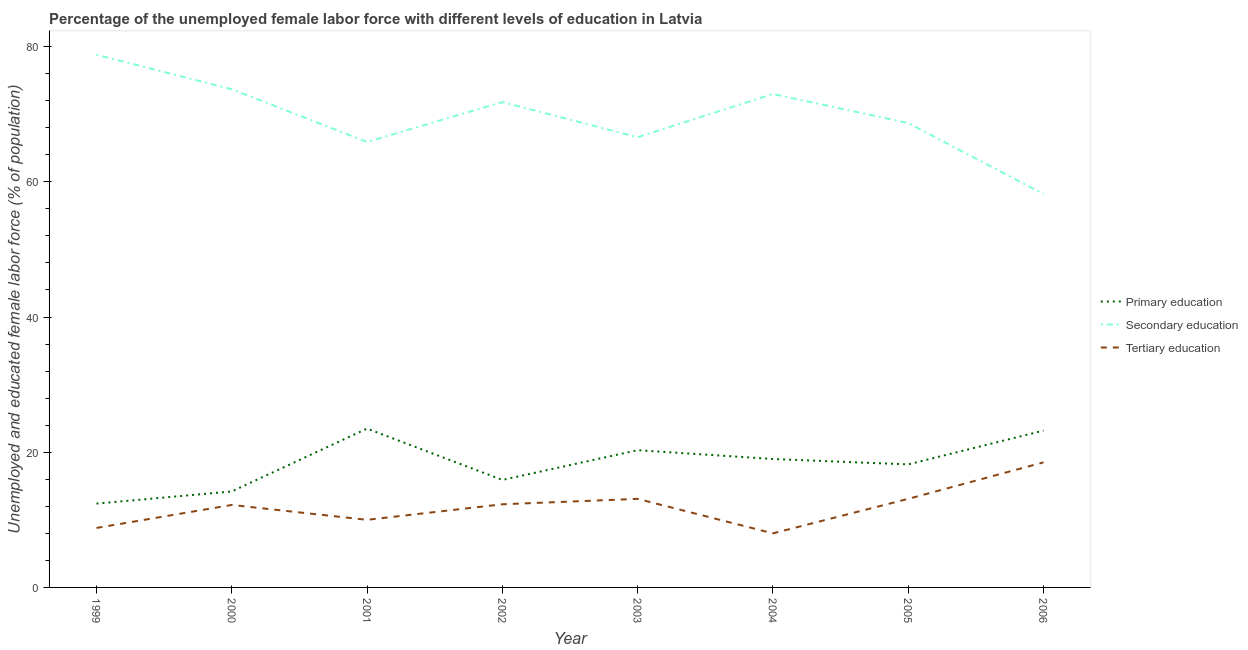How many different coloured lines are there?
Your answer should be very brief. 3. Does the line corresponding to percentage of female labor force who received secondary education intersect with the line corresponding to percentage of female labor force who received tertiary education?
Offer a very short reply. No. What is the percentage of female labor force who received secondary education in 2004?
Give a very brief answer. 73. Across all years, what is the maximum percentage of female labor force who received secondary education?
Make the answer very short. 78.8. What is the total percentage of female labor force who received tertiary education in the graph?
Offer a terse response. 96. What is the difference between the percentage of female labor force who received secondary education in 2001 and that in 2003?
Your answer should be compact. -0.7. What is the difference between the percentage of female labor force who received secondary education in 2005 and the percentage of female labor force who received primary education in 2001?
Your response must be concise. 45.2. What is the average percentage of female labor force who received primary education per year?
Your answer should be compact. 18.34. In how many years, is the percentage of female labor force who received primary education greater than 40 %?
Offer a terse response. 0. What is the ratio of the percentage of female labor force who received secondary education in 2003 to that in 2006?
Provide a short and direct response. 1.14. Is the difference between the percentage of female labor force who received tertiary education in 1999 and 2003 greater than the difference between the percentage of female labor force who received primary education in 1999 and 2003?
Your response must be concise. Yes. What is the difference between the highest and the second highest percentage of female labor force who received tertiary education?
Your answer should be compact. 5.4. What is the difference between the highest and the lowest percentage of female labor force who received secondary education?
Your answer should be compact. 20.6. Is it the case that in every year, the sum of the percentage of female labor force who received primary education and percentage of female labor force who received secondary education is greater than the percentage of female labor force who received tertiary education?
Make the answer very short. Yes. Are the values on the major ticks of Y-axis written in scientific E-notation?
Your answer should be compact. No. Does the graph contain any zero values?
Make the answer very short. No. What is the title of the graph?
Give a very brief answer. Percentage of the unemployed female labor force with different levels of education in Latvia. What is the label or title of the X-axis?
Offer a terse response. Year. What is the label or title of the Y-axis?
Make the answer very short. Unemployed and educated female labor force (% of population). What is the Unemployed and educated female labor force (% of population) in Primary education in 1999?
Ensure brevity in your answer.  12.4. What is the Unemployed and educated female labor force (% of population) in Secondary education in 1999?
Make the answer very short. 78.8. What is the Unemployed and educated female labor force (% of population) of Tertiary education in 1999?
Provide a short and direct response. 8.8. What is the Unemployed and educated female labor force (% of population) in Primary education in 2000?
Give a very brief answer. 14.2. What is the Unemployed and educated female labor force (% of population) of Secondary education in 2000?
Keep it short and to the point. 73.7. What is the Unemployed and educated female labor force (% of population) in Tertiary education in 2000?
Offer a terse response. 12.2. What is the Unemployed and educated female labor force (% of population) in Primary education in 2001?
Offer a terse response. 23.5. What is the Unemployed and educated female labor force (% of population) in Secondary education in 2001?
Provide a short and direct response. 65.9. What is the Unemployed and educated female labor force (% of population) in Tertiary education in 2001?
Your answer should be compact. 10. What is the Unemployed and educated female labor force (% of population) in Primary education in 2002?
Provide a succinct answer. 15.9. What is the Unemployed and educated female labor force (% of population) in Secondary education in 2002?
Provide a succinct answer. 71.8. What is the Unemployed and educated female labor force (% of population) in Tertiary education in 2002?
Provide a succinct answer. 12.3. What is the Unemployed and educated female labor force (% of population) of Primary education in 2003?
Offer a very short reply. 20.3. What is the Unemployed and educated female labor force (% of population) of Secondary education in 2003?
Provide a short and direct response. 66.6. What is the Unemployed and educated female labor force (% of population) in Tertiary education in 2003?
Your answer should be very brief. 13.1. What is the Unemployed and educated female labor force (% of population) in Tertiary education in 2004?
Give a very brief answer. 8. What is the Unemployed and educated female labor force (% of population) in Primary education in 2005?
Give a very brief answer. 18.2. What is the Unemployed and educated female labor force (% of population) of Secondary education in 2005?
Ensure brevity in your answer.  68.7. What is the Unemployed and educated female labor force (% of population) in Tertiary education in 2005?
Offer a terse response. 13.1. What is the Unemployed and educated female labor force (% of population) in Primary education in 2006?
Ensure brevity in your answer.  23.2. What is the Unemployed and educated female labor force (% of population) in Secondary education in 2006?
Give a very brief answer. 58.2. Across all years, what is the maximum Unemployed and educated female labor force (% of population) of Primary education?
Give a very brief answer. 23.5. Across all years, what is the maximum Unemployed and educated female labor force (% of population) of Secondary education?
Your answer should be compact. 78.8. Across all years, what is the minimum Unemployed and educated female labor force (% of population) in Primary education?
Make the answer very short. 12.4. Across all years, what is the minimum Unemployed and educated female labor force (% of population) in Secondary education?
Keep it short and to the point. 58.2. What is the total Unemployed and educated female labor force (% of population) in Primary education in the graph?
Make the answer very short. 146.7. What is the total Unemployed and educated female labor force (% of population) of Secondary education in the graph?
Your answer should be compact. 556.7. What is the total Unemployed and educated female labor force (% of population) in Tertiary education in the graph?
Offer a terse response. 96. What is the difference between the Unemployed and educated female labor force (% of population) of Primary education in 1999 and that in 2000?
Offer a terse response. -1.8. What is the difference between the Unemployed and educated female labor force (% of population) in Secondary education in 1999 and that in 2000?
Provide a short and direct response. 5.1. What is the difference between the Unemployed and educated female labor force (% of population) in Secondary education in 1999 and that in 2001?
Give a very brief answer. 12.9. What is the difference between the Unemployed and educated female labor force (% of population) in Tertiary education in 1999 and that in 2001?
Provide a succinct answer. -1.2. What is the difference between the Unemployed and educated female labor force (% of population) in Primary education in 1999 and that in 2002?
Offer a very short reply. -3.5. What is the difference between the Unemployed and educated female labor force (% of population) of Tertiary education in 1999 and that in 2002?
Offer a terse response. -3.5. What is the difference between the Unemployed and educated female labor force (% of population) of Primary education in 1999 and that in 2003?
Offer a very short reply. -7.9. What is the difference between the Unemployed and educated female labor force (% of population) of Secondary education in 1999 and that in 2003?
Give a very brief answer. 12.2. What is the difference between the Unemployed and educated female labor force (% of population) of Primary education in 1999 and that in 2004?
Offer a very short reply. -6.6. What is the difference between the Unemployed and educated female labor force (% of population) in Tertiary education in 1999 and that in 2004?
Make the answer very short. 0.8. What is the difference between the Unemployed and educated female labor force (% of population) in Secondary education in 1999 and that in 2005?
Offer a terse response. 10.1. What is the difference between the Unemployed and educated female labor force (% of population) of Primary education in 1999 and that in 2006?
Provide a short and direct response. -10.8. What is the difference between the Unemployed and educated female labor force (% of population) in Secondary education in 1999 and that in 2006?
Provide a succinct answer. 20.6. What is the difference between the Unemployed and educated female labor force (% of population) of Tertiary education in 1999 and that in 2006?
Keep it short and to the point. -9.7. What is the difference between the Unemployed and educated female labor force (% of population) in Secondary education in 2000 and that in 2001?
Provide a short and direct response. 7.8. What is the difference between the Unemployed and educated female labor force (% of population) of Tertiary education in 2000 and that in 2001?
Provide a succinct answer. 2.2. What is the difference between the Unemployed and educated female labor force (% of population) of Primary education in 2000 and that in 2002?
Provide a short and direct response. -1.7. What is the difference between the Unemployed and educated female labor force (% of population) in Primary education in 2000 and that in 2003?
Offer a very short reply. -6.1. What is the difference between the Unemployed and educated female labor force (% of population) of Secondary education in 2000 and that in 2003?
Your response must be concise. 7.1. What is the difference between the Unemployed and educated female labor force (% of population) of Tertiary education in 2000 and that in 2003?
Offer a very short reply. -0.9. What is the difference between the Unemployed and educated female labor force (% of population) in Secondary education in 2000 and that in 2004?
Your response must be concise. 0.7. What is the difference between the Unemployed and educated female labor force (% of population) of Tertiary education in 2000 and that in 2004?
Ensure brevity in your answer.  4.2. What is the difference between the Unemployed and educated female labor force (% of population) of Secondary education in 2000 and that in 2005?
Your response must be concise. 5. What is the difference between the Unemployed and educated female labor force (% of population) in Primary education in 2000 and that in 2006?
Make the answer very short. -9. What is the difference between the Unemployed and educated female labor force (% of population) in Secondary education in 2000 and that in 2006?
Provide a short and direct response. 15.5. What is the difference between the Unemployed and educated female labor force (% of population) in Tertiary education in 2000 and that in 2006?
Your answer should be very brief. -6.3. What is the difference between the Unemployed and educated female labor force (% of population) in Primary education in 2001 and that in 2002?
Your response must be concise. 7.6. What is the difference between the Unemployed and educated female labor force (% of population) in Secondary education in 2001 and that in 2002?
Offer a very short reply. -5.9. What is the difference between the Unemployed and educated female labor force (% of population) of Tertiary education in 2001 and that in 2002?
Ensure brevity in your answer.  -2.3. What is the difference between the Unemployed and educated female labor force (% of population) of Secondary education in 2001 and that in 2003?
Give a very brief answer. -0.7. What is the difference between the Unemployed and educated female labor force (% of population) in Tertiary education in 2001 and that in 2003?
Give a very brief answer. -3.1. What is the difference between the Unemployed and educated female labor force (% of population) in Primary education in 2001 and that in 2004?
Offer a terse response. 4.5. What is the difference between the Unemployed and educated female labor force (% of population) of Secondary education in 2001 and that in 2004?
Offer a terse response. -7.1. What is the difference between the Unemployed and educated female labor force (% of population) in Tertiary education in 2001 and that in 2004?
Provide a short and direct response. 2. What is the difference between the Unemployed and educated female labor force (% of population) in Secondary education in 2001 and that in 2005?
Your answer should be compact. -2.8. What is the difference between the Unemployed and educated female labor force (% of population) in Tertiary education in 2001 and that in 2005?
Ensure brevity in your answer.  -3.1. What is the difference between the Unemployed and educated female labor force (% of population) in Primary education in 2001 and that in 2006?
Provide a short and direct response. 0.3. What is the difference between the Unemployed and educated female labor force (% of population) in Tertiary education in 2001 and that in 2006?
Provide a short and direct response. -8.5. What is the difference between the Unemployed and educated female labor force (% of population) in Secondary education in 2002 and that in 2003?
Keep it short and to the point. 5.2. What is the difference between the Unemployed and educated female labor force (% of population) of Tertiary education in 2002 and that in 2003?
Ensure brevity in your answer.  -0.8. What is the difference between the Unemployed and educated female labor force (% of population) in Primary education in 2002 and that in 2004?
Offer a very short reply. -3.1. What is the difference between the Unemployed and educated female labor force (% of population) of Secondary education in 2002 and that in 2004?
Provide a succinct answer. -1.2. What is the difference between the Unemployed and educated female labor force (% of population) in Tertiary education in 2002 and that in 2004?
Provide a short and direct response. 4.3. What is the difference between the Unemployed and educated female labor force (% of population) in Primary education in 2002 and that in 2005?
Give a very brief answer. -2.3. What is the difference between the Unemployed and educated female labor force (% of population) in Secondary education in 2002 and that in 2005?
Ensure brevity in your answer.  3.1. What is the difference between the Unemployed and educated female labor force (% of population) of Primary education in 2002 and that in 2006?
Your response must be concise. -7.3. What is the difference between the Unemployed and educated female labor force (% of population) in Tertiary education in 2002 and that in 2006?
Your answer should be compact. -6.2. What is the difference between the Unemployed and educated female labor force (% of population) in Primary education in 2003 and that in 2004?
Offer a terse response. 1.3. What is the difference between the Unemployed and educated female labor force (% of population) of Secondary education in 2003 and that in 2004?
Ensure brevity in your answer.  -6.4. What is the difference between the Unemployed and educated female labor force (% of population) of Tertiary education in 2003 and that in 2004?
Your answer should be compact. 5.1. What is the difference between the Unemployed and educated female labor force (% of population) of Secondary education in 2003 and that in 2006?
Your response must be concise. 8.4. What is the difference between the Unemployed and educated female labor force (% of population) in Tertiary education in 2003 and that in 2006?
Keep it short and to the point. -5.4. What is the difference between the Unemployed and educated female labor force (% of population) in Primary education in 2004 and that in 2005?
Offer a terse response. 0.8. What is the difference between the Unemployed and educated female labor force (% of population) of Secondary education in 2004 and that in 2005?
Your answer should be compact. 4.3. What is the difference between the Unemployed and educated female labor force (% of population) of Tertiary education in 2004 and that in 2005?
Provide a short and direct response. -5.1. What is the difference between the Unemployed and educated female labor force (% of population) of Primary education in 2004 and that in 2006?
Provide a succinct answer. -4.2. What is the difference between the Unemployed and educated female labor force (% of population) in Secondary education in 2004 and that in 2006?
Your answer should be very brief. 14.8. What is the difference between the Unemployed and educated female labor force (% of population) of Primary education in 2005 and that in 2006?
Offer a very short reply. -5. What is the difference between the Unemployed and educated female labor force (% of population) in Secondary education in 2005 and that in 2006?
Offer a terse response. 10.5. What is the difference between the Unemployed and educated female labor force (% of population) in Tertiary education in 2005 and that in 2006?
Your response must be concise. -5.4. What is the difference between the Unemployed and educated female labor force (% of population) of Primary education in 1999 and the Unemployed and educated female labor force (% of population) of Secondary education in 2000?
Give a very brief answer. -61.3. What is the difference between the Unemployed and educated female labor force (% of population) of Primary education in 1999 and the Unemployed and educated female labor force (% of population) of Tertiary education in 2000?
Give a very brief answer. 0.2. What is the difference between the Unemployed and educated female labor force (% of population) of Secondary education in 1999 and the Unemployed and educated female labor force (% of population) of Tertiary education in 2000?
Your answer should be compact. 66.6. What is the difference between the Unemployed and educated female labor force (% of population) in Primary education in 1999 and the Unemployed and educated female labor force (% of population) in Secondary education in 2001?
Your answer should be very brief. -53.5. What is the difference between the Unemployed and educated female labor force (% of population) in Secondary education in 1999 and the Unemployed and educated female labor force (% of population) in Tertiary education in 2001?
Keep it short and to the point. 68.8. What is the difference between the Unemployed and educated female labor force (% of population) of Primary education in 1999 and the Unemployed and educated female labor force (% of population) of Secondary education in 2002?
Offer a terse response. -59.4. What is the difference between the Unemployed and educated female labor force (% of population) in Secondary education in 1999 and the Unemployed and educated female labor force (% of population) in Tertiary education in 2002?
Your response must be concise. 66.5. What is the difference between the Unemployed and educated female labor force (% of population) in Primary education in 1999 and the Unemployed and educated female labor force (% of population) in Secondary education in 2003?
Ensure brevity in your answer.  -54.2. What is the difference between the Unemployed and educated female labor force (% of population) of Secondary education in 1999 and the Unemployed and educated female labor force (% of population) of Tertiary education in 2003?
Offer a very short reply. 65.7. What is the difference between the Unemployed and educated female labor force (% of population) in Primary education in 1999 and the Unemployed and educated female labor force (% of population) in Secondary education in 2004?
Make the answer very short. -60.6. What is the difference between the Unemployed and educated female labor force (% of population) of Primary education in 1999 and the Unemployed and educated female labor force (% of population) of Tertiary education in 2004?
Your response must be concise. 4.4. What is the difference between the Unemployed and educated female labor force (% of population) of Secondary education in 1999 and the Unemployed and educated female labor force (% of population) of Tertiary education in 2004?
Provide a succinct answer. 70.8. What is the difference between the Unemployed and educated female labor force (% of population) in Primary education in 1999 and the Unemployed and educated female labor force (% of population) in Secondary education in 2005?
Offer a very short reply. -56.3. What is the difference between the Unemployed and educated female labor force (% of population) of Primary education in 1999 and the Unemployed and educated female labor force (% of population) of Tertiary education in 2005?
Offer a very short reply. -0.7. What is the difference between the Unemployed and educated female labor force (% of population) in Secondary education in 1999 and the Unemployed and educated female labor force (% of population) in Tertiary education in 2005?
Provide a short and direct response. 65.7. What is the difference between the Unemployed and educated female labor force (% of population) of Primary education in 1999 and the Unemployed and educated female labor force (% of population) of Secondary education in 2006?
Offer a terse response. -45.8. What is the difference between the Unemployed and educated female labor force (% of population) in Primary education in 1999 and the Unemployed and educated female labor force (% of population) in Tertiary education in 2006?
Provide a short and direct response. -6.1. What is the difference between the Unemployed and educated female labor force (% of population) in Secondary education in 1999 and the Unemployed and educated female labor force (% of population) in Tertiary education in 2006?
Your answer should be compact. 60.3. What is the difference between the Unemployed and educated female labor force (% of population) in Primary education in 2000 and the Unemployed and educated female labor force (% of population) in Secondary education in 2001?
Provide a succinct answer. -51.7. What is the difference between the Unemployed and educated female labor force (% of population) in Primary education in 2000 and the Unemployed and educated female labor force (% of population) in Tertiary education in 2001?
Offer a terse response. 4.2. What is the difference between the Unemployed and educated female labor force (% of population) in Secondary education in 2000 and the Unemployed and educated female labor force (% of population) in Tertiary education in 2001?
Make the answer very short. 63.7. What is the difference between the Unemployed and educated female labor force (% of population) of Primary education in 2000 and the Unemployed and educated female labor force (% of population) of Secondary education in 2002?
Offer a very short reply. -57.6. What is the difference between the Unemployed and educated female labor force (% of population) of Primary education in 2000 and the Unemployed and educated female labor force (% of population) of Tertiary education in 2002?
Keep it short and to the point. 1.9. What is the difference between the Unemployed and educated female labor force (% of population) in Secondary education in 2000 and the Unemployed and educated female labor force (% of population) in Tertiary education in 2002?
Give a very brief answer. 61.4. What is the difference between the Unemployed and educated female labor force (% of population) of Primary education in 2000 and the Unemployed and educated female labor force (% of population) of Secondary education in 2003?
Your response must be concise. -52.4. What is the difference between the Unemployed and educated female labor force (% of population) in Secondary education in 2000 and the Unemployed and educated female labor force (% of population) in Tertiary education in 2003?
Make the answer very short. 60.6. What is the difference between the Unemployed and educated female labor force (% of population) of Primary education in 2000 and the Unemployed and educated female labor force (% of population) of Secondary education in 2004?
Your response must be concise. -58.8. What is the difference between the Unemployed and educated female labor force (% of population) of Primary education in 2000 and the Unemployed and educated female labor force (% of population) of Tertiary education in 2004?
Your answer should be very brief. 6.2. What is the difference between the Unemployed and educated female labor force (% of population) in Secondary education in 2000 and the Unemployed and educated female labor force (% of population) in Tertiary education in 2004?
Keep it short and to the point. 65.7. What is the difference between the Unemployed and educated female labor force (% of population) in Primary education in 2000 and the Unemployed and educated female labor force (% of population) in Secondary education in 2005?
Offer a terse response. -54.5. What is the difference between the Unemployed and educated female labor force (% of population) in Secondary education in 2000 and the Unemployed and educated female labor force (% of population) in Tertiary education in 2005?
Offer a terse response. 60.6. What is the difference between the Unemployed and educated female labor force (% of population) in Primary education in 2000 and the Unemployed and educated female labor force (% of population) in Secondary education in 2006?
Your answer should be very brief. -44. What is the difference between the Unemployed and educated female labor force (% of population) in Primary education in 2000 and the Unemployed and educated female labor force (% of population) in Tertiary education in 2006?
Offer a terse response. -4.3. What is the difference between the Unemployed and educated female labor force (% of population) of Secondary education in 2000 and the Unemployed and educated female labor force (% of population) of Tertiary education in 2006?
Ensure brevity in your answer.  55.2. What is the difference between the Unemployed and educated female labor force (% of population) in Primary education in 2001 and the Unemployed and educated female labor force (% of population) in Secondary education in 2002?
Offer a very short reply. -48.3. What is the difference between the Unemployed and educated female labor force (% of population) in Secondary education in 2001 and the Unemployed and educated female labor force (% of population) in Tertiary education in 2002?
Your answer should be compact. 53.6. What is the difference between the Unemployed and educated female labor force (% of population) in Primary education in 2001 and the Unemployed and educated female labor force (% of population) in Secondary education in 2003?
Ensure brevity in your answer.  -43.1. What is the difference between the Unemployed and educated female labor force (% of population) of Primary education in 2001 and the Unemployed and educated female labor force (% of population) of Tertiary education in 2003?
Offer a very short reply. 10.4. What is the difference between the Unemployed and educated female labor force (% of population) of Secondary education in 2001 and the Unemployed and educated female labor force (% of population) of Tertiary education in 2003?
Ensure brevity in your answer.  52.8. What is the difference between the Unemployed and educated female labor force (% of population) in Primary education in 2001 and the Unemployed and educated female labor force (% of population) in Secondary education in 2004?
Your answer should be compact. -49.5. What is the difference between the Unemployed and educated female labor force (% of population) in Primary education in 2001 and the Unemployed and educated female labor force (% of population) in Tertiary education in 2004?
Ensure brevity in your answer.  15.5. What is the difference between the Unemployed and educated female labor force (% of population) in Secondary education in 2001 and the Unemployed and educated female labor force (% of population) in Tertiary education in 2004?
Offer a very short reply. 57.9. What is the difference between the Unemployed and educated female labor force (% of population) of Primary education in 2001 and the Unemployed and educated female labor force (% of population) of Secondary education in 2005?
Give a very brief answer. -45.2. What is the difference between the Unemployed and educated female labor force (% of population) in Secondary education in 2001 and the Unemployed and educated female labor force (% of population) in Tertiary education in 2005?
Provide a succinct answer. 52.8. What is the difference between the Unemployed and educated female labor force (% of population) of Primary education in 2001 and the Unemployed and educated female labor force (% of population) of Secondary education in 2006?
Give a very brief answer. -34.7. What is the difference between the Unemployed and educated female labor force (% of population) in Secondary education in 2001 and the Unemployed and educated female labor force (% of population) in Tertiary education in 2006?
Offer a terse response. 47.4. What is the difference between the Unemployed and educated female labor force (% of population) of Primary education in 2002 and the Unemployed and educated female labor force (% of population) of Secondary education in 2003?
Give a very brief answer. -50.7. What is the difference between the Unemployed and educated female labor force (% of population) in Secondary education in 2002 and the Unemployed and educated female labor force (% of population) in Tertiary education in 2003?
Keep it short and to the point. 58.7. What is the difference between the Unemployed and educated female labor force (% of population) of Primary education in 2002 and the Unemployed and educated female labor force (% of population) of Secondary education in 2004?
Your response must be concise. -57.1. What is the difference between the Unemployed and educated female labor force (% of population) of Secondary education in 2002 and the Unemployed and educated female labor force (% of population) of Tertiary education in 2004?
Your answer should be compact. 63.8. What is the difference between the Unemployed and educated female labor force (% of population) in Primary education in 2002 and the Unemployed and educated female labor force (% of population) in Secondary education in 2005?
Your response must be concise. -52.8. What is the difference between the Unemployed and educated female labor force (% of population) of Primary education in 2002 and the Unemployed and educated female labor force (% of population) of Tertiary education in 2005?
Provide a short and direct response. 2.8. What is the difference between the Unemployed and educated female labor force (% of population) of Secondary education in 2002 and the Unemployed and educated female labor force (% of population) of Tertiary education in 2005?
Ensure brevity in your answer.  58.7. What is the difference between the Unemployed and educated female labor force (% of population) in Primary education in 2002 and the Unemployed and educated female labor force (% of population) in Secondary education in 2006?
Your response must be concise. -42.3. What is the difference between the Unemployed and educated female labor force (% of population) of Primary education in 2002 and the Unemployed and educated female labor force (% of population) of Tertiary education in 2006?
Give a very brief answer. -2.6. What is the difference between the Unemployed and educated female labor force (% of population) of Secondary education in 2002 and the Unemployed and educated female labor force (% of population) of Tertiary education in 2006?
Ensure brevity in your answer.  53.3. What is the difference between the Unemployed and educated female labor force (% of population) in Primary education in 2003 and the Unemployed and educated female labor force (% of population) in Secondary education in 2004?
Ensure brevity in your answer.  -52.7. What is the difference between the Unemployed and educated female labor force (% of population) in Primary education in 2003 and the Unemployed and educated female labor force (% of population) in Tertiary education in 2004?
Your answer should be compact. 12.3. What is the difference between the Unemployed and educated female labor force (% of population) in Secondary education in 2003 and the Unemployed and educated female labor force (% of population) in Tertiary education in 2004?
Provide a short and direct response. 58.6. What is the difference between the Unemployed and educated female labor force (% of population) of Primary education in 2003 and the Unemployed and educated female labor force (% of population) of Secondary education in 2005?
Ensure brevity in your answer.  -48.4. What is the difference between the Unemployed and educated female labor force (% of population) in Secondary education in 2003 and the Unemployed and educated female labor force (% of population) in Tertiary education in 2005?
Give a very brief answer. 53.5. What is the difference between the Unemployed and educated female labor force (% of population) of Primary education in 2003 and the Unemployed and educated female labor force (% of population) of Secondary education in 2006?
Make the answer very short. -37.9. What is the difference between the Unemployed and educated female labor force (% of population) in Primary education in 2003 and the Unemployed and educated female labor force (% of population) in Tertiary education in 2006?
Keep it short and to the point. 1.8. What is the difference between the Unemployed and educated female labor force (% of population) in Secondary education in 2003 and the Unemployed and educated female labor force (% of population) in Tertiary education in 2006?
Keep it short and to the point. 48.1. What is the difference between the Unemployed and educated female labor force (% of population) of Primary education in 2004 and the Unemployed and educated female labor force (% of population) of Secondary education in 2005?
Provide a succinct answer. -49.7. What is the difference between the Unemployed and educated female labor force (% of population) in Primary education in 2004 and the Unemployed and educated female labor force (% of population) in Tertiary education in 2005?
Your answer should be compact. 5.9. What is the difference between the Unemployed and educated female labor force (% of population) in Secondary education in 2004 and the Unemployed and educated female labor force (% of population) in Tertiary education in 2005?
Your answer should be very brief. 59.9. What is the difference between the Unemployed and educated female labor force (% of population) of Primary education in 2004 and the Unemployed and educated female labor force (% of population) of Secondary education in 2006?
Provide a short and direct response. -39.2. What is the difference between the Unemployed and educated female labor force (% of population) in Primary education in 2004 and the Unemployed and educated female labor force (% of population) in Tertiary education in 2006?
Ensure brevity in your answer.  0.5. What is the difference between the Unemployed and educated female labor force (% of population) in Secondary education in 2004 and the Unemployed and educated female labor force (% of population) in Tertiary education in 2006?
Make the answer very short. 54.5. What is the difference between the Unemployed and educated female labor force (% of population) of Secondary education in 2005 and the Unemployed and educated female labor force (% of population) of Tertiary education in 2006?
Offer a very short reply. 50.2. What is the average Unemployed and educated female labor force (% of population) in Primary education per year?
Your answer should be compact. 18.34. What is the average Unemployed and educated female labor force (% of population) in Secondary education per year?
Offer a terse response. 69.59. In the year 1999, what is the difference between the Unemployed and educated female labor force (% of population) of Primary education and Unemployed and educated female labor force (% of population) of Secondary education?
Keep it short and to the point. -66.4. In the year 2000, what is the difference between the Unemployed and educated female labor force (% of population) of Primary education and Unemployed and educated female labor force (% of population) of Secondary education?
Your response must be concise. -59.5. In the year 2000, what is the difference between the Unemployed and educated female labor force (% of population) of Primary education and Unemployed and educated female labor force (% of population) of Tertiary education?
Ensure brevity in your answer.  2. In the year 2000, what is the difference between the Unemployed and educated female labor force (% of population) in Secondary education and Unemployed and educated female labor force (% of population) in Tertiary education?
Your answer should be very brief. 61.5. In the year 2001, what is the difference between the Unemployed and educated female labor force (% of population) in Primary education and Unemployed and educated female labor force (% of population) in Secondary education?
Your answer should be compact. -42.4. In the year 2001, what is the difference between the Unemployed and educated female labor force (% of population) in Secondary education and Unemployed and educated female labor force (% of population) in Tertiary education?
Give a very brief answer. 55.9. In the year 2002, what is the difference between the Unemployed and educated female labor force (% of population) of Primary education and Unemployed and educated female labor force (% of population) of Secondary education?
Make the answer very short. -55.9. In the year 2002, what is the difference between the Unemployed and educated female labor force (% of population) of Primary education and Unemployed and educated female labor force (% of population) of Tertiary education?
Your response must be concise. 3.6. In the year 2002, what is the difference between the Unemployed and educated female labor force (% of population) of Secondary education and Unemployed and educated female labor force (% of population) of Tertiary education?
Keep it short and to the point. 59.5. In the year 2003, what is the difference between the Unemployed and educated female labor force (% of population) in Primary education and Unemployed and educated female labor force (% of population) in Secondary education?
Your answer should be very brief. -46.3. In the year 2003, what is the difference between the Unemployed and educated female labor force (% of population) in Primary education and Unemployed and educated female labor force (% of population) in Tertiary education?
Keep it short and to the point. 7.2. In the year 2003, what is the difference between the Unemployed and educated female labor force (% of population) of Secondary education and Unemployed and educated female labor force (% of population) of Tertiary education?
Give a very brief answer. 53.5. In the year 2004, what is the difference between the Unemployed and educated female labor force (% of population) of Primary education and Unemployed and educated female labor force (% of population) of Secondary education?
Ensure brevity in your answer.  -54. In the year 2004, what is the difference between the Unemployed and educated female labor force (% of population) in Primary education and Unemployed and educated female labor force (% of population) in Tertiary education?
Offer a terse response. 11. In the year 2005, what is the difference between the Unemployed and educated female labor force (% of population) in Primary education and Unemployed and educated female labor force (% of population) in Secondary education?
Offer a very short reply. -50.5. In the year 2005, what is the difference between the Unemployed and educated female labor force (% of population) of Primary education and Unemployed and educated female labor force (% of population) of Tertiary education?
Provide a short and direct response. 5.1. In the year 2005, what is the difference between the Unemployed and educated female labor force (% of population) of Secondary education and Unemployed and educated female labor force (% of population) of Tertiary education?
Ensure brevity in your answer.  55.6. In the year 2006, what is the difference between the Unemployed and educated female labor force (% of population) of Primary education and Unemployed and educated female labor force (% of population) of Secondary education?
Offer a very short reply. -35. In the year 2006, what is the difference between the Unemployed and educated female labor force (% of population) in Secondary education and Unemployed and educated female labor force (% of population) in Tertiary education?
Your answer should be very brief. 39.7. What is the ratio of the Unemployed and educated female labor force (% of population) in Primary education in 1999 to that in 2000?
Provide a short and direct response. 0.87. What is the ratio of the Unemployed and educated female labor force (% of population) of Secondary education in 1999 to that in 2000?
Offer a terse response. 1.07. What is the ratio of the Unemployed and educated female labor force (% of population) of Tertiary education in 1999 to that in 2000?
Your answer should be compact. 0.72. What is the ratio of the Unemployed and educated female labor force (% of population) in Primary education in 1999 to that in 2001?
Ensure brevity in your answer.  0.53. What is the ratio of the Unemployed and educated female labor force (% of population) of Secondary education in 1999 to that in 2001?
Keep it short and to the point. 1.2. What is the ratio of the Unemployed and educated female labor force (% of population) of Primary education in 1999 to that in 2002?
Ensure brevity in your answer.  0.78. What is the ratio of the Unemployed and educated female labor force (% of population) in Secondary education in 1999 to that in 2002?
Offer a terse response. 1.1. What is the ratio of the Unemployed and educated female labor force (% of population) of Tertiary education in 1999 to that in 2002?
Ensure brevity in your answer.  0.72. What is the ratio of the Unemployed and educated female labor force (% of population) of Primary education in 1999 to that in 2003?
Offer a very short reply. 0.61. What is the ratio of the Unemployed and educated female labor force (% of population) of Secondary education in 1999 to that in 2003?
Offer a terse response. 1.18. What is the ratio of the Unemployed and educated female labor force (% of population) of Tertiary education in 1999 to that in 2003?
Ensure brevity in your answer.  0.67. What is the ratio of the Unemployed and educated female labor force (% of population) of Primary education in 1999 to that in 2004?
Offer a very short reply. 0.65. What is the ratio of the Unemployed and educated female labor force (% of population) of Secondary education in 1999 to that in 2004?
Your answer should be compact. 1.08. What is the ratio of the Unemployed and educated female labor force (% of population) of Tertiary education in 1999 to that in 2004?
Ensure brevity in your answer.  1.1. What is the ratio of the Unemployed and educated female labor force (% of population) of Primary education in 1999 to that in 2005?
Ensure brevity in your answer.  0.68. What is the ratio of the Unemployed and educated female labor force (% of population) of Secondary education in 1999 to that in 2005?
Keep it short and to the point. 1.15. What is the ratio of the Unemployed and educated female labor force (% of population) of Tertiary education in 1999 to that in 2005?
Provide a succinct answer. 0.67. What is the ratio of the Unemployed and educated female labor force (% of population) in Primary education in 1999 to that in 2006?
Give a very brief answer. 0.53. What is the ratio of the Unemployed and educated female labor force (% of population) in Secondary education in 1999 to that in 2006?
Give a very brief answer. 1.35. What is the ratio of the Unemployed and educated female labor force (% of population) in Tertiary education in 1999 to that in 2006?
Your answer should be very brief. 0.48. What is the ratio of the Unemployed and educated female labor force (% of population) of Primary education in 2000 to that in 2001?
Offer a very short reply. 0.6. What is the ratio of the Unemployed and educated female labor force (% of population) in Secondary education in 2000 to that in 2001?
Your answer should be compact. 1.12. What is the ratio of the Unemployed and educated female labor force (% of population) of Tertiary education in 2000 to that in 2001?
Provide a succinct answer. 1.22. What is the ratio of the Unemployed and educated female labor force (% of population) in Primary education in 2000 to that in 2002?
Offer a terse response. 0.89. What is the ratio of the Unemployed and educated female labor force (% of population) of Secondary education in 2000 to that in 2002?
Offer a very short reply. 1.03. What is the ratio of the Unemployed and educated female labor force (% of population) of Tertiary education in 2000 to that in 2002?
Ensure brevity in your answer.  0.99. What is the ratio of the Unemployed and educated female labor force (% of population) of Primary education in 2000 to that in 2003?
Offer a very short reply. 0.7. What is the ratio of the Unemployed and educated female labor force (% of population) of Secondary education in 2000 to that in 2003?
Keep it short and to the point. 1.11. What is the ratio of the Unemployed and educated female labor force (% of population) of Tertiary education in 2000 to that in 2003?
Your answer should be very brief. 0.93. What is the ratio of the Unemployed and educated female labor force (% of population) in Primary education in 2000 to that in 2004?
Give a very brief answer. 0.75. What is the ratio of the Unemployed and educated female labor force (% of population) of Secondary education in 2000 to that in 2004?
Your answer should be very brief. 1.01. What is the ratio of the Unemployed and educated female labor force (% of population) in Tertiary education in 2000 to that in 2004?
Give a very brief answer. 1.52. What is the ratio of the Unemployed and educated female labor force (% of population) in Primary education in 2000 to that in 2005?
Make the answer very short. 0.78. What is the ratio of the Unemployed and educated female labor force (% of population) of Secondary education in 2000 to that in 2005?
Make the answer very short. 1.07. What is the ratio of the Unemployed and educated female labor force (% of population) in Tertiary education in 2000 to that in 2005?
Give a very brief answer. 0.93. What is the ratio of the Unemployed and educated female labor force (% of population) in Primary education in 2000 to that in 2006?
Give a very brief answer. 0.61. What is the ratio of the Unemployed and educated female labor force (% of population) of Secondary education in 2000 to that in 2006?
Offer a very short reply. 1.27. What is the ratio of the Unemployed and educated female labor force (% of population) in Tertiary education in 2000 to that in 2006?
Offer a terse response. 0.66. What is the ratio of the Unemployed and educated female labor force (% of population) of Primary education in 2001 to that in 2002?
Keep it short and to the point. 1.48. What is the ratio of the Unemployed and educated female labor force (% of population) of Secondary education in 2001 to that in 2002?
Give a very brief answer. 0.92. What is the ratio of the Unemployed and educated female labor force (% of population) in Tertiary education in 2001 to that in 2002?
Keep it short and to the point. 0.81. What is the ratio of the Unemployed and educated female labor force (% of population) in Primary education in 2001 to that in 2003?
Your answer should be compact. 1.16. What is the ratio of the Unemployed and educated female labor force (% of population) of Tertiary education in 2001 to that in 2003?
Make the answer very short. 0.76. What is the ratio of the Unemployed and educated female labor force (% of population) of Primary education in 2001 to that in 2004?
Your answer should be compact. 1.24. What is the ratio of the Unemployed and educated female labor force (% of population) of Secondary education in 2001 to that in 2004?
Give a very brief answer. 0.9. What is the ratio of the Unemployed and educated female labor force (% of population) in Primary education in 2001 to that in 2005?
Your answer should be compact. 1.29. What is the ratio of the Unemployed and educated female labor force (% of population) in Secondary education in 2001 to that in 2005?
Offer a very short reply. 0.96. What is the ratio of the Unemployed and educated female labor force (% of population) of Tertiary education in 2001 to that in 2005?
Your answer should be very brief. 0.76. What is the ratio of the Unemployed and educated female labor force (% of population) in Primary education in 2001 to that in 2006?
Give a very brief answer. 1.01. What is the ratio of the Unemployed and educated female labor force (% of population) of Secondary education in 2001 to that in 2006?
Offer a very short reply. 1.13. What is the ratio of the Unemployed and educated female labor force (% of population) in Tertiary education in 2001 to that in 2006?
Provide a short and direct response. 0.54. What is the ratio of the Unemployed and educated female labor force (% of population) of Primary education in 2002 to that in 2003?
Your answer should be very brief. 0.78. What is the ratio of the Unemployed and educated female labor force (% of population) of Secondary education in 2002 to that in 2003?
Your answer should be very brief. 1.08. What is the ratio of the Unemployed and educated female labor force (% of population) of Tertiary education in 2002 to that in 2003?
Give a very brief answer. 0.94. What is the ratio of the Unemployed and educated female labor force (% of population) of Primary education in 2002 to that in 2004?
Your answer should be compact. 0.84. What is the ratio of the Unemployed and educated female labor force (% of population) of Secondary education in 2002 to that in 2004?
Make the answer very short. 0.98. What is the ratio of the Unemployed and educated female labor force (% of population) in Tertiary education in 2002 to that in 2004?
Ensure brevity in your answer.  1.54. What is the ratio of the Unemployed and educated female labor force (% of population) of Primary education in 2002 to that in 2005?
Provide a short and direct response. 0.87. What is the ratio of the Unemployed and educated female labor force (% of population) in Secondary education in 2002 to that in 2005?
Offer a very short reply. 1.05. What is the ratio of the Unemployed and educated female labor force (% of population) of Tertiary education in 2002 to that in 2005?
Your response must be concise. 0.94. What is the ratio of the Unemployed and educated female labor force (% of population) in Primary education in 2002 to that in 2006?
Offer a terse response. 0.69. What is the ratio of the Unemployed and educated female labor force (% of population) of Secondary education in 2002 to that in 2006?
Make the answer very short. 1.23. What is the ratio of the Unemployed and educated female labor force (% of population) of Tertiary education in 2002 to that in 2006?
Your response must be concise. 0.66. What is the ratio of the Unemployed and educated female labor force (% of population) in Primary education in 2003 to that in 2004?
Your response must be concise. 1.07. What is the ratio of the Unemployed and educated female labor force (% of population) of Secondary education in 2003 to that in 2004?
Offer a terse response. 0.91. What is the ratio of the Unemployed and educated female labor force (% of population) of Tertiary education in 2003 to that in 2004?
Keep it short and to the point. 1.64. What is the ratio of the Unemployed and educated female labor force (% of population) in Primary education in 2003 to that in 2005?
Ensure brevity in your answer.  1.12. What is the ratio of the Unemployed and educated female labor force (% of population) in Secondary education in 2003 to that in 2005?
Your response must be concise. 0.97. What is the ratio of the Unemployed and educated female labor force (% of population) in Secondary education in 2003 to that in 2006?
Keep it short and to the point. 1.14. What is the ratio of the Unemployed and educated female labor force (% of population) of Tertiary education in 2003 to that in 2006?
Your response must be concise. 0.71. What is the ratio of the Unemployed and educated female labor force (% of population) in Primary education in 2004 to that in 2005?
Keep it short and to the point. 1.04. What is the ratio of the Unemployed and educated female labor force (% of population) in Secondary education in 2004 to that in 2005?
Offer a terse response. 1.06. What is the ratio of the Unemployed and educated female labor force (% of population) of Tertiary education in 2004 to that in 2005?
Offer a very short reply. 0.61. What is the ratio of the Unemployed and educated female labor force (% of population) in Primary education in 2004 to that in 2006?
Your response must be concise. 0.82. What is the ratio of the Unemployed and educated female labor force (% of population) of Secondary education in 2004 to that in 2006?
Your answer should be compact. 1.25. What is the ratio of the Unemployed and educated female labor force (% of population) in Tertiary education in 2004 to that in 2006?
Your answer should be very brief. 0.43. What is the ratio of the Unemployed and educated female labor force (% of population) in Primary education in 2005 to that in 2006?
Provide a succinct answer. 0.78. What is the ratio of the Unemployed and educated female labor force (% of population) in Secondary education in 2005 to that in 2006?
Give a very brief answer. 1.18. What is the ratio of the Unemployed and educated female labor force (% of population) of Tertiary education in 2005 to that in 2006?
Provide a short and direct response. 0.71. What is the difference between the highest and the second highest Unemployed and educated female labor force (% of population) of Primary education?
Make the answer very short. 0.3. What is the difference between the highest and the lowest Unemployed and educated female labor force (% of population) of Primary education?
Your answer should be very brief. 11.1. What is the difference between the highest and the lowest Unemployed and educated female labor force (% of population) of Secondary education?
Give a very brief answer. 20.6. What is the difference between the highest and the lowest Unemployed and educated female labor force (% of population) in Tertiary education?
Provide a short and direct response. 10.5. 